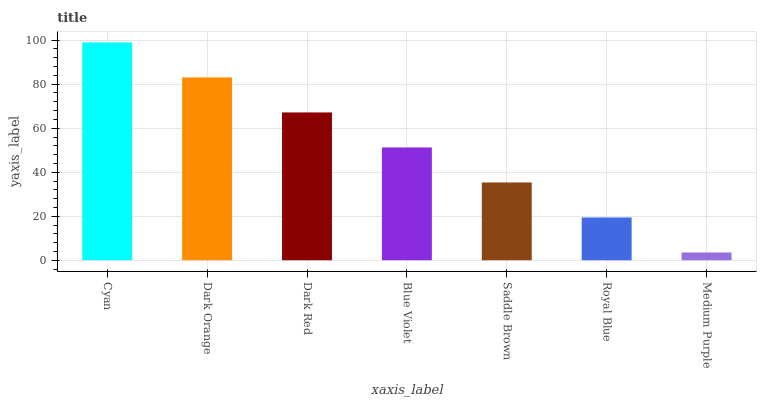Is Dark Orange the minimum?
Answer yes or no. No. Is Dark Orange the maximum?
Answer yes or no. No. Is Cyan greater than Dark Orange?
Answer yes or no. Yes. Is Dark Orange less than Cyan?
Answer yes or no. Yes. Is Dark Orange greater than Cyan?
Answer yes or no. No. Is Cyan less than Dark Orange?
Answer yes or no. No. Is Blue Violet the high median?
Answer yes or no. Yes. Is Blue Violet the low median?
Answer yes or no. Yes. Is Medium Purple the high median?
Answer yes or no. No. Is Cyan the low median?
Answer yes or no. No. 